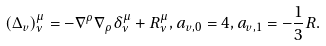Convert formula to latex. <formula><loc_0><loc_0><loc_500><loc_500>( \Delta _ { v } ) ^ { \mu } _ { \nu } = - \nabla ^ { \rho } \nabla _ { \rho } \delta ^ { \mu } _ { \nu } + R ^ { \mu } _ { \nu } , a _ { v , 0 } = 4 , a _ { v , 1 } = - \frac { 1 } { 3 } R .</formula> 